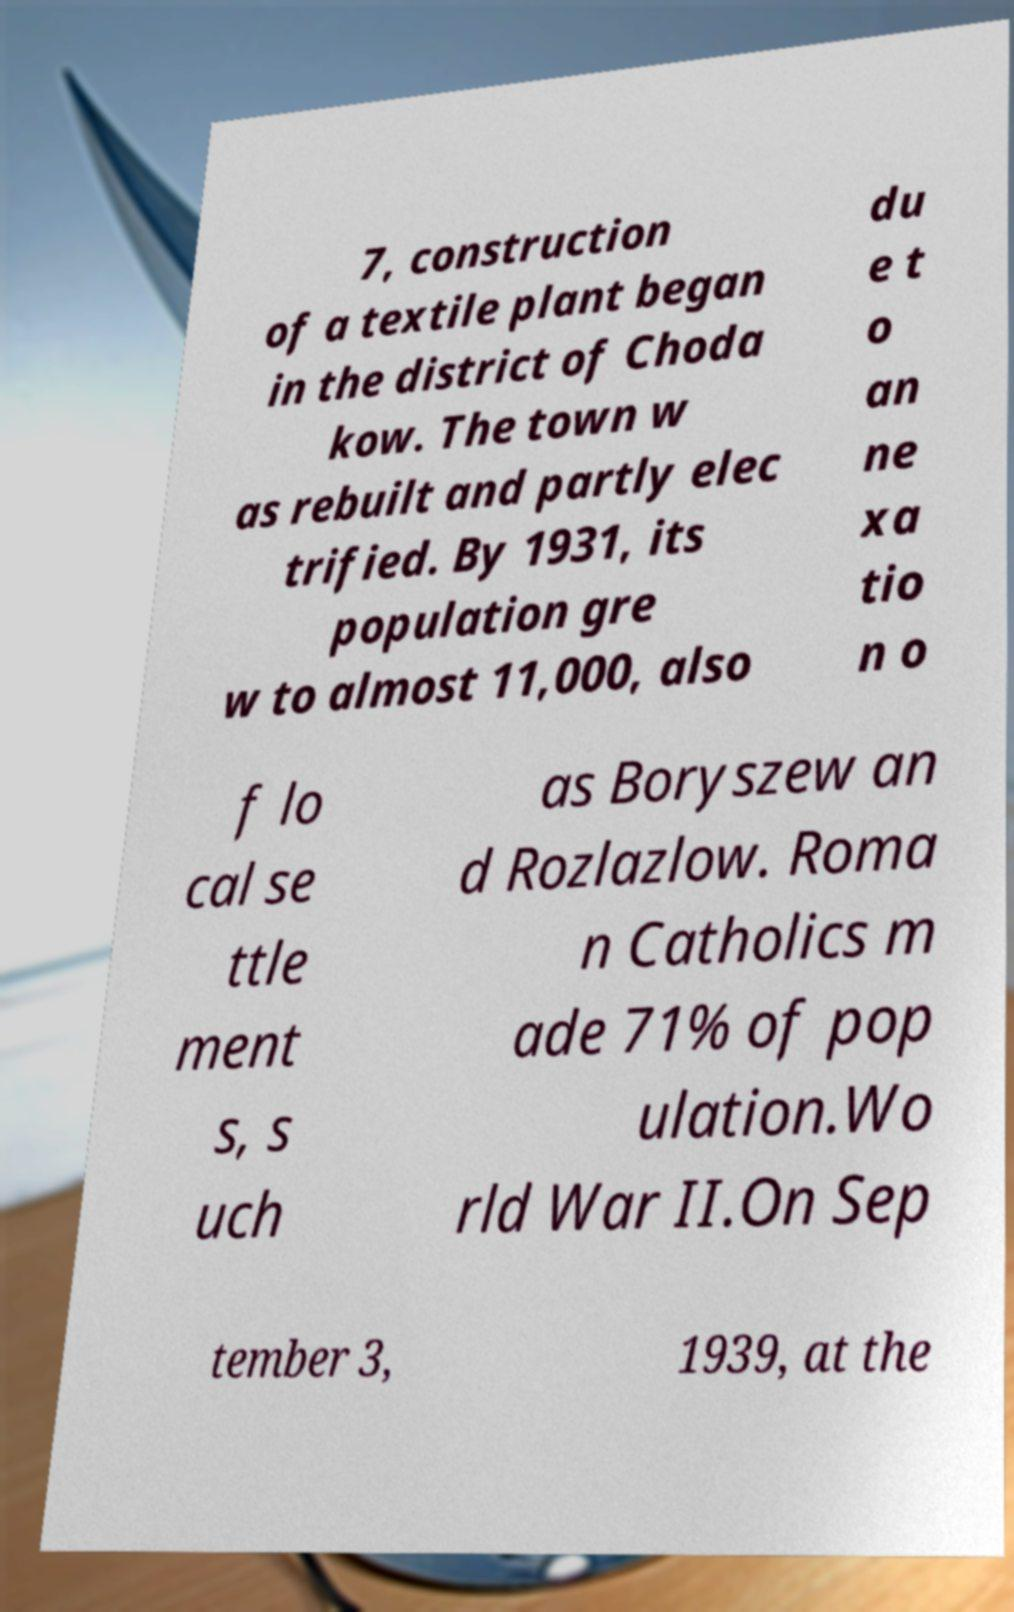For documentation purposes, I need the text within this image transcribed. Could you provide that? 7, construction of a textile plant began in the district of Choda kow. The town w as rebuilt and partly elec trified. By 1931, its population gre w to almost 11,000, also du e t o an ne xa tio n o f lo cal se ttle ment s, s uch as Boryszew an d Rozlazlow. Roma n Catholics m ade 71% of pop ulation.Wo rld War II.On Sep tember 3, 1939, at the 